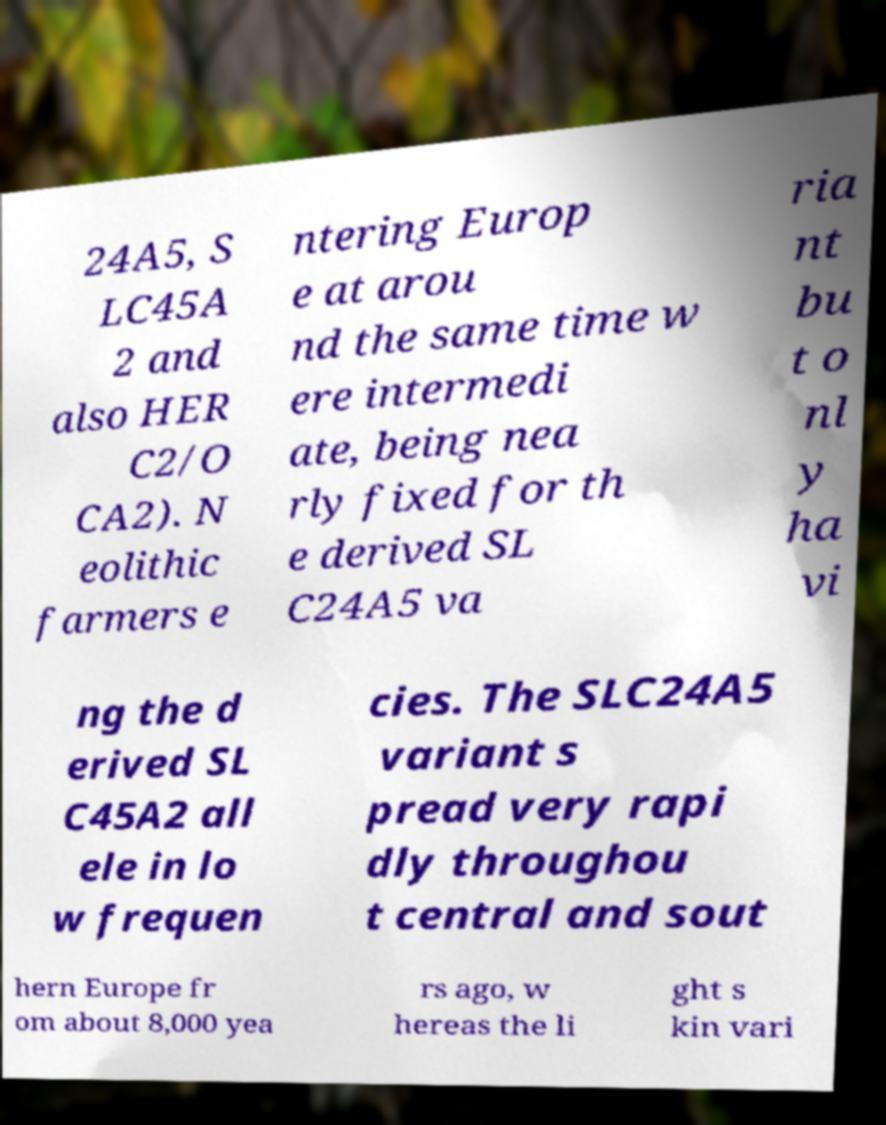What messages or text are displayed in this image? I need them in a readable, typed format. 24A5, S LC45A 2 and also HER C2/O CA2). N eolithic farmers e ntering Europ e at arou nd the same time w ere intermedi ate, being nea rly fixed for th e derived SL C24A5 va ria nt bu t o nl y ha vi ng the d erived SL C45A2 all ele in lo w frequen cies. The SLC24A5 variant s pread very rapi dly throughou t central and sout hern Europe fr om about 8,000 yea rs ago, w hereas the li ght s kin vari 